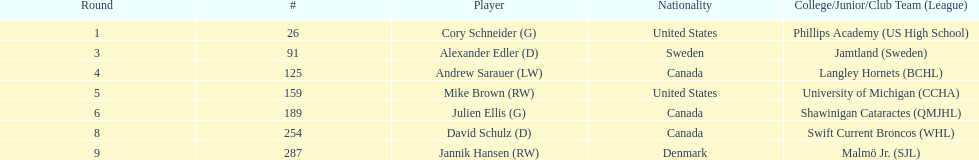List each player drafted from canada. Andrew Sarauer (LW), Julien Ellis (G), David Schulz (D). Can you parse all the data within this table? {'header': ['Round', '#', 'Player', 'Nationality', 'College/Junior/Club Team (League)'], 'rows': [['1', '26', 'Cory Schneider (G)', 'United States', 'Phillips Academy (US High School)'], ['3', '91', 'Alexander Edler (D)', 'Sweden', 'Jamtland (Sweden)'], ['4', '125', 'Andrew Sarauer (LW)', 'Canada', 'Langley Hornets (BCHL)'], ['5', '159', 'Mike Brown (RW)', 'United States', 'University of Michigan (CCHA)'], ['6', '189', 'Julien Ellis (G)', 'Canada', 'Shawinigan Cataractes (QMJHL)'], ['8', '254', 'David Schulz (D)', 'Canada', 'Swift Current Broncos (WHL)'], ['9', '287', 'Jannik Hansen (RW)', 'Denmark', 'Malmö Jr. (SJL)']]} 